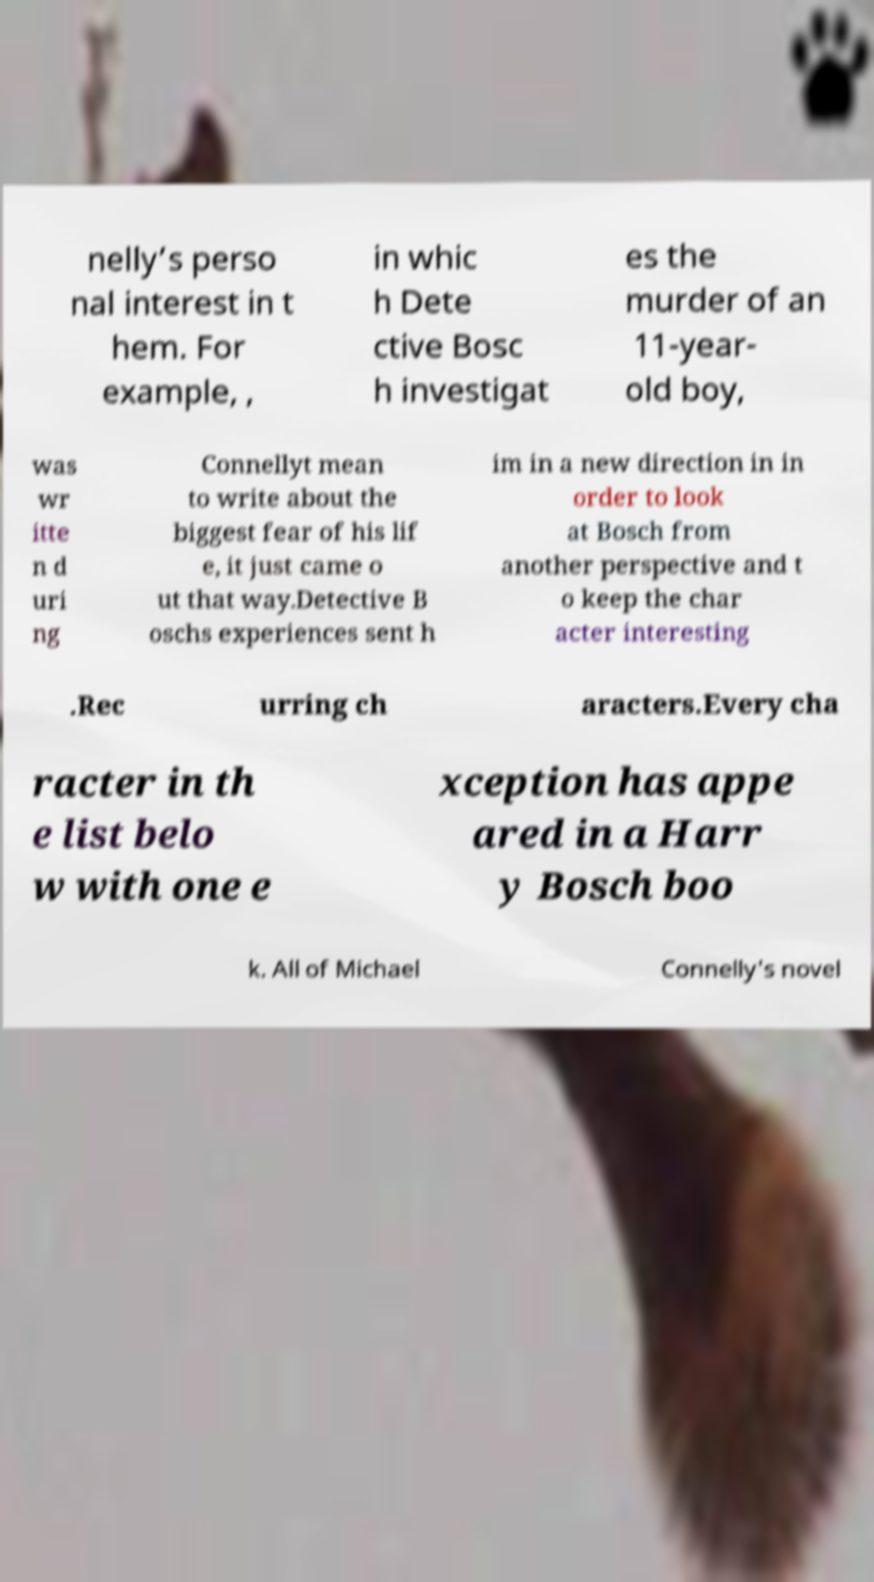Please read and relay the text visible in this image. What does it say? nelly’s perso nal interest in t hem. For example, , in whic h Dete ctive Bosc h investigat es the murder of an 11-year- old boy, was wr itte n d uri ng Connellyt mean to write about the biggest fear of his lif e, it just came o ut that way.Detective B oschs experiences sent h im in a new direction in in order to look at Bosch from another perspective and t o keep the char acter interesting .Rec urring ch aracters.Every cha racter in th e list belo w with one e xception has appe ared in a Harr y Bosch boo k. All of Michael Connelly's novel 